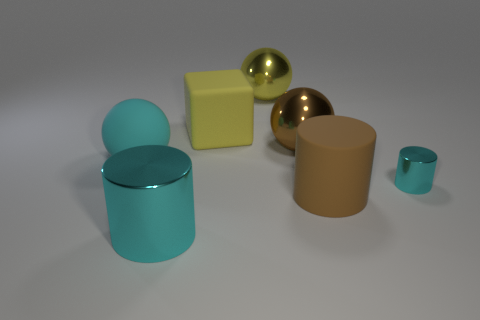What is the material of the ball that is in front of the large yellow shiny sphere and left of the big brown metal sphere?
Provide a succinct answer. Rubber. The sphere that is the same color as the block is what size?
Give a very brief answer. Large. What number of other things are there of the same size as the yellow matte block?
Provide a succinct answer. 5. What is the ball that is behind the big brown metallic thing made of?
Your response must be concise. Metal. Do the big brown rubber thing and the big yellow rubber object have the same shape?
Ensure brevity in your answer.  No. How many other things are the same shape as the brown matte thing?
Make the answer very short. 2. The metal thing that is right of the brown matte cylinder is what color?
Offer a very short reply. Cyan. Is the brown metal ball the same size as the rubber ball?
Your response must be concise. Yes. The brown thing that is behind the cyan thing left of the large cyan cylinder is made of what material?
Your response must be concise. Metal. How many rubber objects are the same color as the big matte cube?
Offer a terse response. 0. 